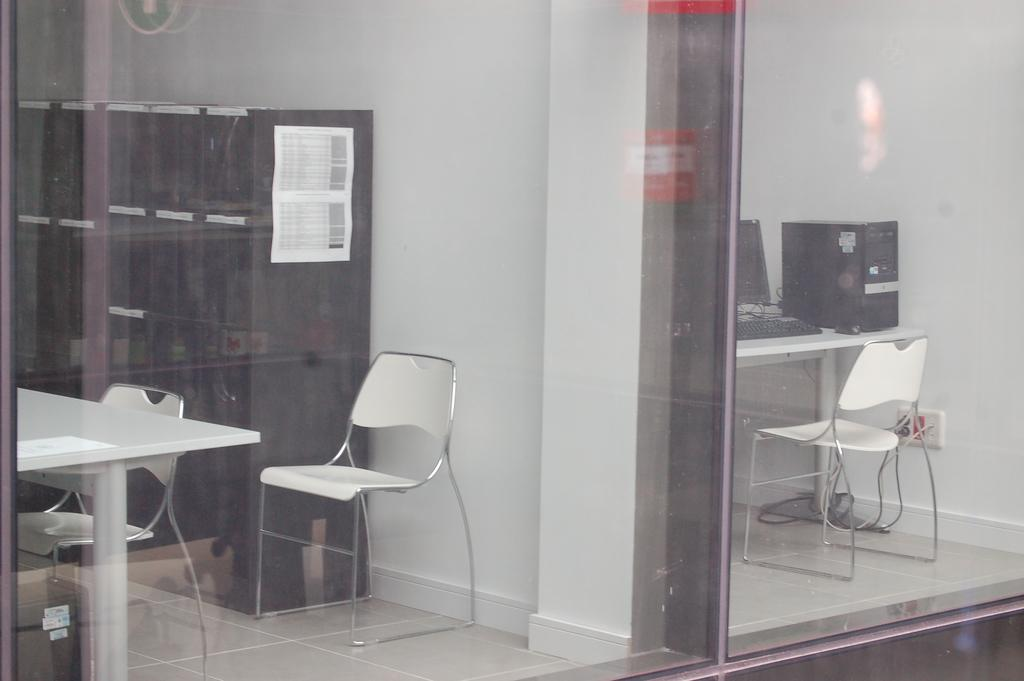What type of furniture is present in the image? There are chairs and a table in the image. What is placed on the table? A computer is placed on the table. What other piece of furniture can be seen in the image? There is a wardrobe in the image. What type of fear can be seen on the face of the ant in the image? There are no ants present in the image, and therefore no fear can be observed. 